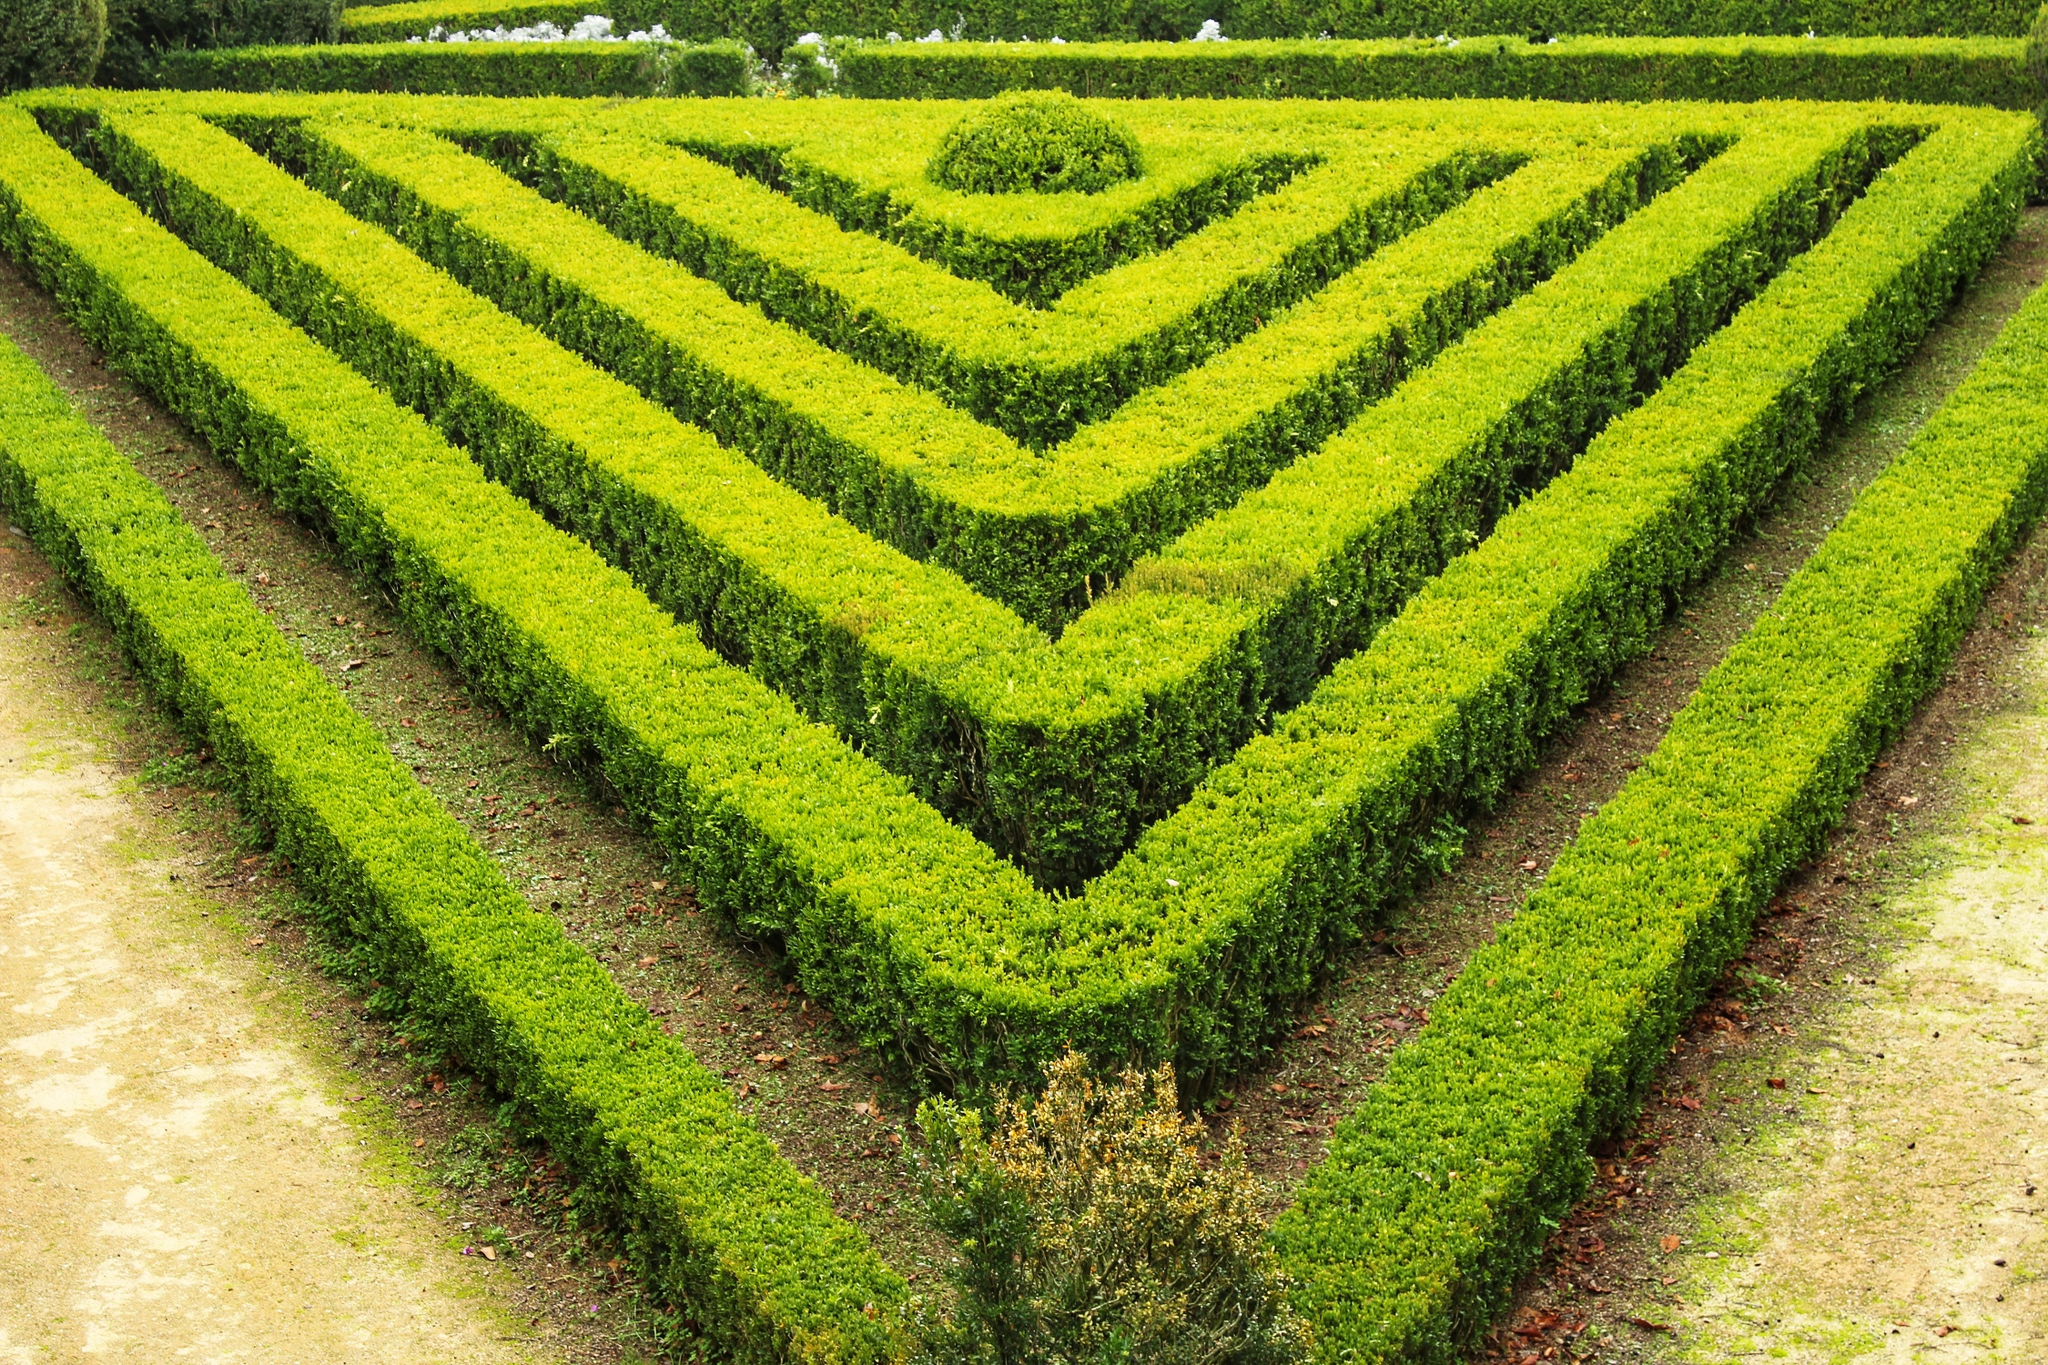What seasonal changes might affect the appearance of this garden? The garden's appearance would shift dramatically with the changing seasons. In spring, the shrubs would be lush and vibrant, with a fresh green hue that signifies new growth. Small flowers might bloom among the shrubs, adding pops of color and enhancing the garden's visual appeal. During summer, the garden would be at its peak, with the foliage being dense and richly colored, providing a cool, shaded retreat from the heat. Come autumn, the shrubs might take on various shades of yellow and orange, creating a warm, inviting atmosphere. Leaves from the small trees would fall, adding a layer of texture to the pathways. In winter, the garden would exhibit a starker beauty; the shrubs would remain, but their leaves might be sparse or frosted, and the overall scene could be quieter and more austere. 